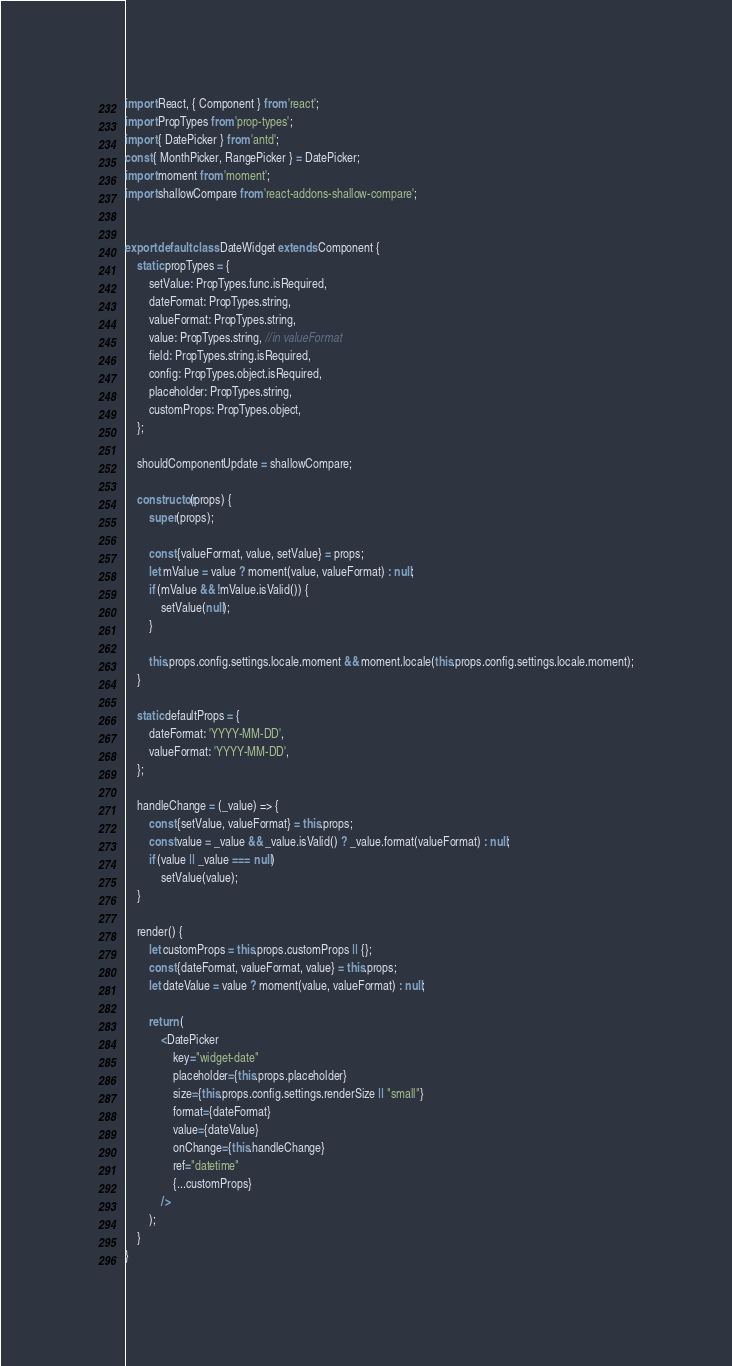Convert code to text. <code><loc_0><loc_0><loc_500><loc_500><_JavaScript_>import React, { Component } from 'react';
import PropTypes from 'prop-types';
import { DatePicker } from 'antd';
const { MonthPicker, RangePicker } = DatePicker;
import moment from 'moment';
import shallowCompare from 'react-addons-shallow-compare';


export default class DateWidget extends Component {
    static propTypes = {
        setValue: PropTypes.func.isRequired,
        dateFormat: PropTypes.string,
        valueFormat: PropTypes.string,
        value: PropTypes.string, //in valueFormat
        field: PropTypes.string.isRequired,
        config: PropTypes.object.isRequired,
        placeholder: PropTypes.string,
        customProps: PropTypes.object,
    };

    shouldComponentUpdate = shallowCompare;

    constructor(props) {
        super(props);

        const {valueFormat, value, setValue} = props;
        let mValue = value ? moment(value, valueFormat) : null;
        if (mValue && !mValue.isValid()) {
            setValue(null);
        }

        this.props.config.settings.locale.moment && moment.locale(this.props.config.settings.locale.moment);
    }

    static defaultProps = {
        dateFormat: 'YYYY-MM-DD',
        valueFormat: 'YYYY-MM-DD',
    };

    handleChange = (_value) => {
        const {setValue, valueFormat} = this.props;
        const value = _value && _value.isValid() ? _value.format(valueFormat) : null;
        if (value || _value === null)
            setValue(value);
    }

    render() {
        let customProps = this.props.customProps || {};
        const {dateFormat, valueFormat, value} = this.props;
        let dateValue = value ? moment(value, valueFormat) : null;

        return (
            <DatePicker
                key="widget-date"
                placeholder={this.props.placeholder}
                size={this.props.config.settings.renderSize || "small"}
                format={dateFormat}
                value={dateValue}
                onChange={this.handleChange}
                ref="datetime"
                {...customProps}
            />
        );
    }
}
</code> 